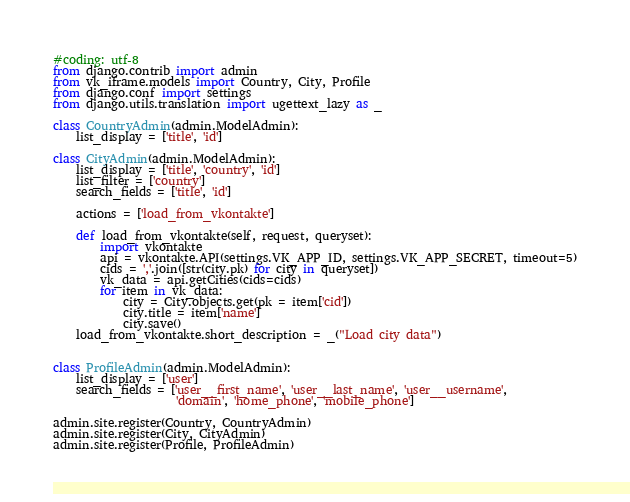<code> <loc_0><loc_0><loc_500><loc_500><_Python_>#coding: utf-8
from django.contrib import admin
from vk_iframe.models import Country, City, Profile
from django.conf import settings
from django.utils.translation import ugettext_lazy as _

class CountryAdmin(admin.ModelAdmin):
    list_display = ['title', 'id']

class CityAdmin(admin.ModelAdmin):
    list_display = ['title', 'country', 'id']
    list_filter = ['country']
    search_fields = ['title', 'id']

    actions = ['load_from_vkontakte']

    def load_from_vkontakte(self, request, queryset):
        import vkontakte
        api = vkontakte.API(settings.VK_APP_ID, settings.VK_APP_SECRET, timeout=5)
        cids = ','.join([str(city.pk) for city in queryset])
        vk_data = api.getCities(cids=cids)
        for item in vk_data:
            city = City.objects.get(pk = item['cid'])
            city.title = item['name']
            city.save()
    load_from_vkontakte.short_description = _("Load city data")


class ProfileAdmin(admin.ModelAdmin):
    list_display = ['user']
    search_fields = ['user__first_name', 'user__last_name', 'user__username',
                     'domain', 'home_phone', 'mobile_phone']

admin.site.register(Country, CountryAdmin)
admin.site.register(City, CityAdmin)
admin.site.register(Profile, ProfileAdmin)
</code> 